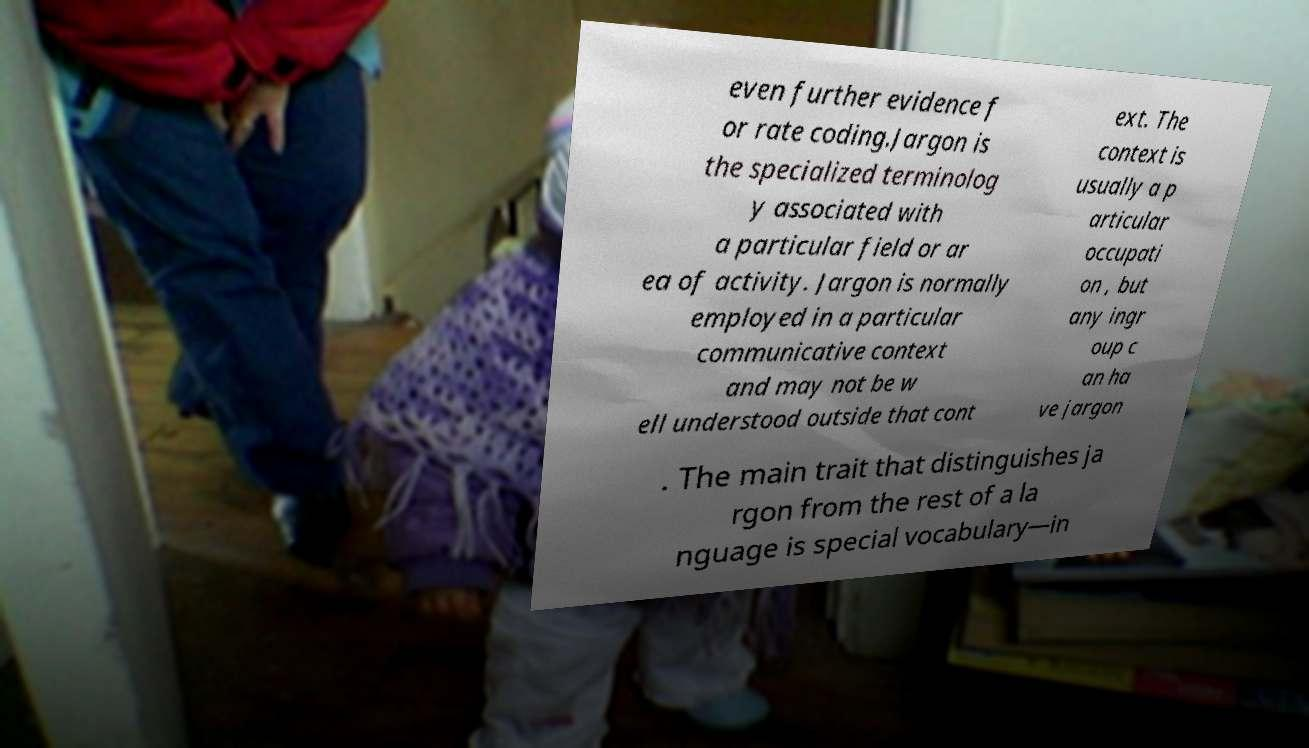For documentation purposes, I need the text within this image transcribed. Could you provide that? even further evidence f or rate coding.Jargon is the specialized terminolog y associated with a particular field or ar ea of activity. Jargon is normally employed in a particular communicative context and may not be w ell understood outside that cont ext. The context is usually a p articular occupati on , but any ingr oup c an ha ve jargon . The main trait that distinguishes ja rgon from the rest of a la nguage is special vocabulary—in 